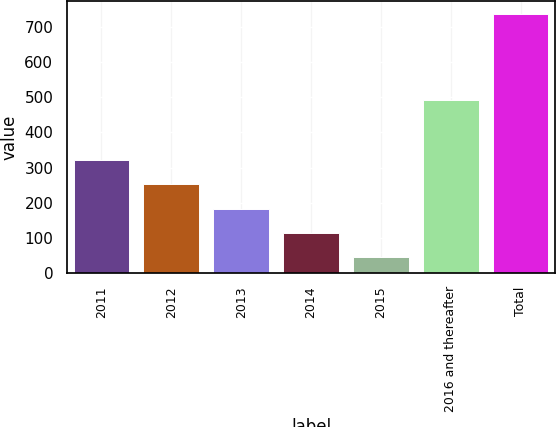Convert chart. <chart><loc_0><loc_0><loc_500><loc_500><bar_chart><fcel>2011<fcel>2012<fcel>2013<fcel>2014<fcel>2015<fcel>2016 and thereafter<fcel>Total<nl><fcel>321.8<fcel>252.6<fcel>183.4<fcel>114.2<fcel>45<fcel>493<fcel>737<nl></chart> 